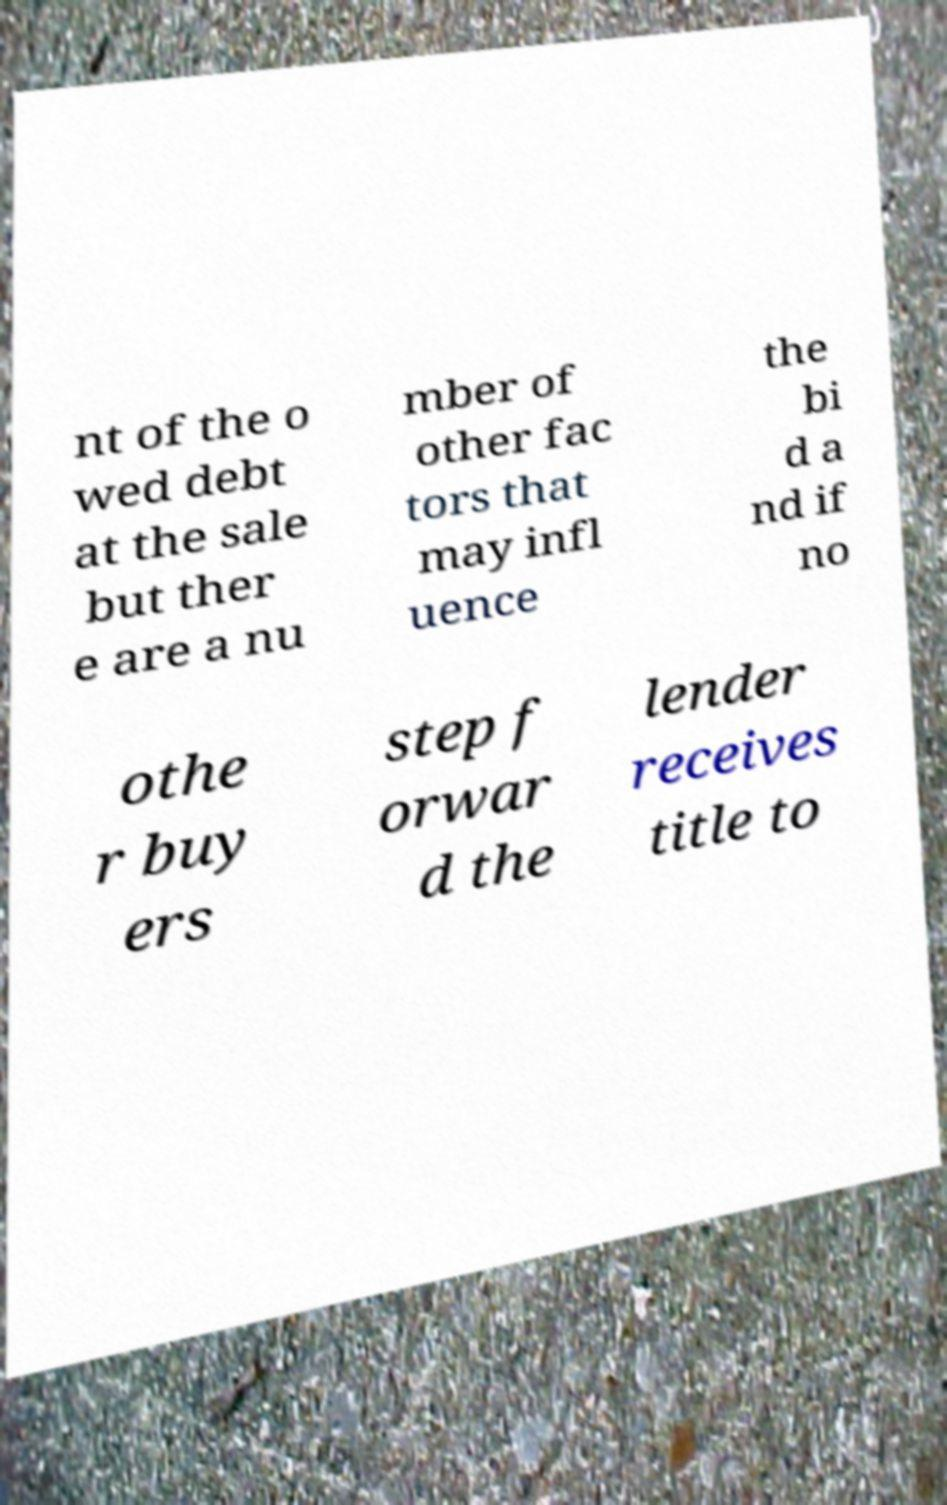For documentation purposes, I need the text within this image transcribed. Could you provide that? nt of the o wed debt at the sale but ther e are a nu mber of other fac tors that may infl uence the bi d a nd if no othe r buy ers step f orwar d the lender receives title to 